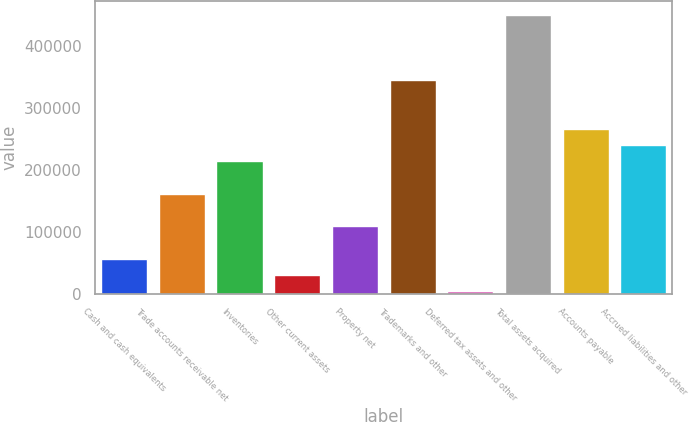Convert chart to OTSL. <chart><loc_0><loc_0><loc_500><loc_500><bar_chart><fcel>Cash and cash equivalents<fcel>Trade accounts receivable net<fcel>Inventories<fcel>Other current assets<fcel>Property net<fcel>Trademarks and other<fcel>Deferred tax assets and other<fcel>Total assets acquired<fcel>Accounts payable<fcel>Accrued liabilities and other<nl><fcel>56213.2<fcel>161086<fcel>213522<fcel>29995.1<fcel>108649<fcel>344612<fcel>3777<fcel>449485<fcel>265958<fcel>239740<nl></chart> 